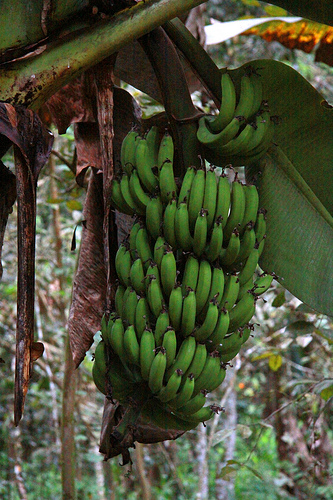Please provide a short description for this region: [0.52, 0.73, 0.55, 0.76]. This area likely features a slightly decayed part of the banana. 